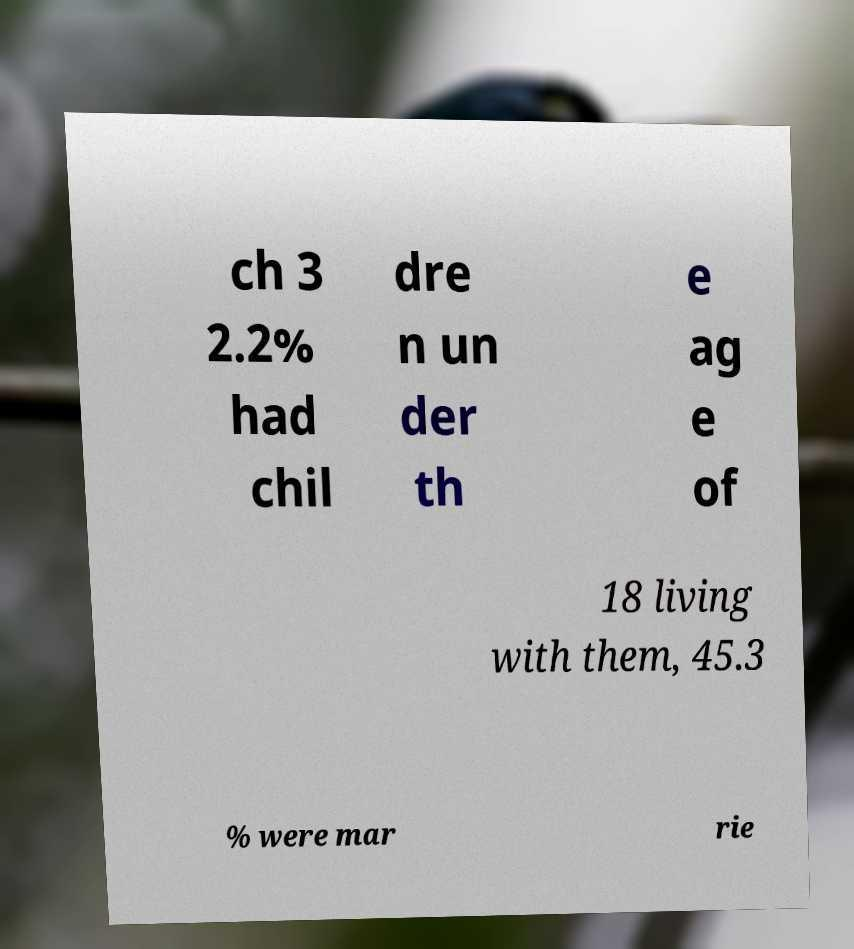What messages or text are displayed in this image? I need them in a readable, typed format. ch 3 2.2% had chil dre n un der th e ag e of 18 living with them, 45.3 % were mar rie 